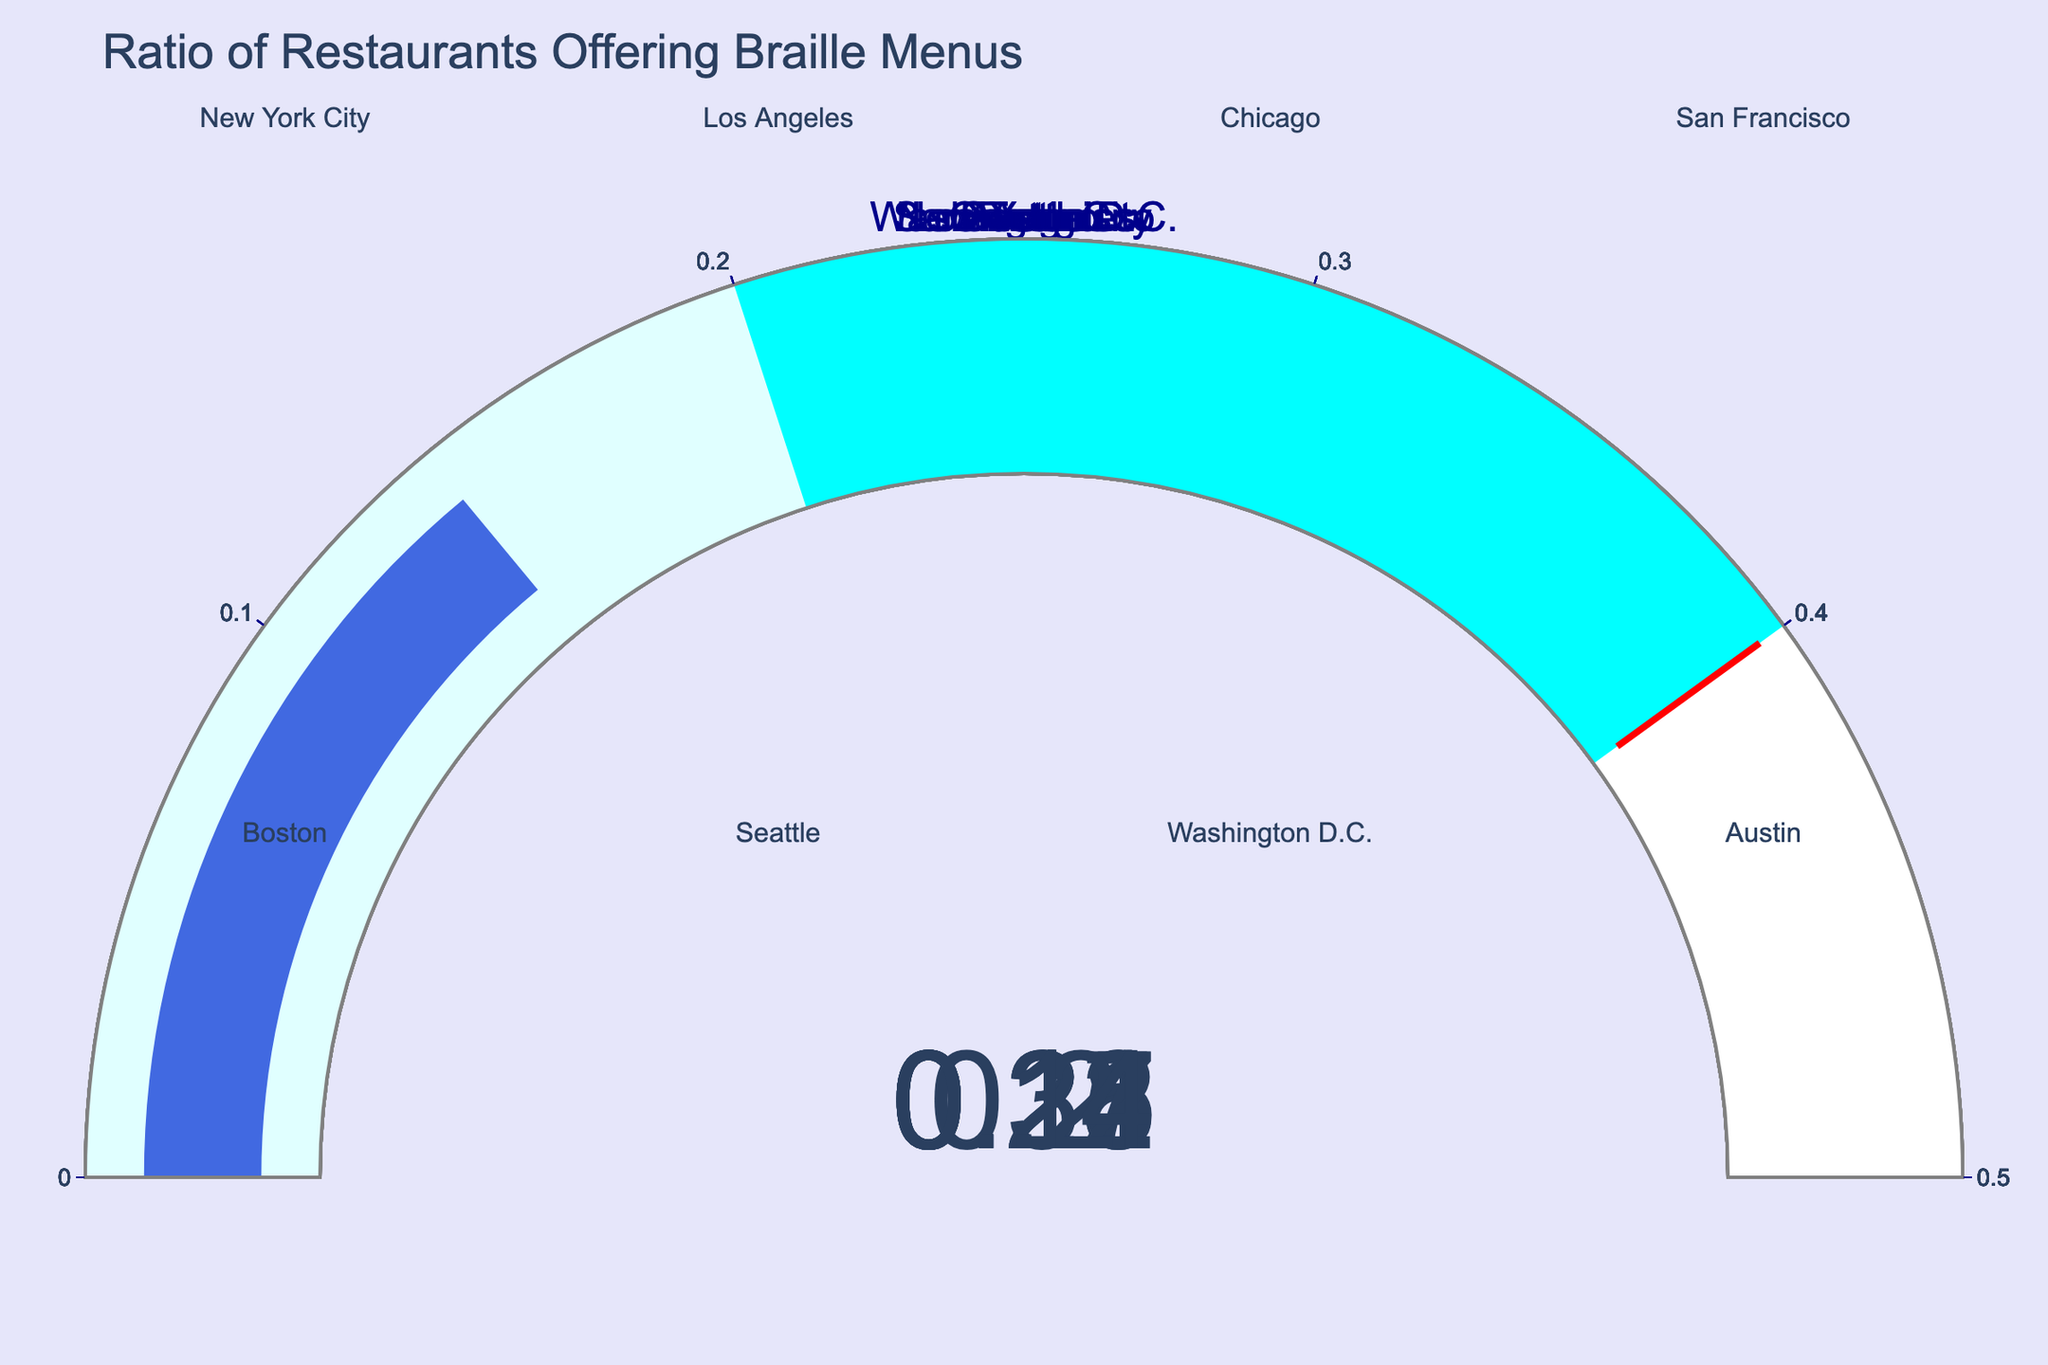What's the ratio of restaurants offering braille menus in San Francisco? The gauge for San Francisco shows a value representing the ratio of restaurants offering braille menus. Looking at the gauge, the value is 0.31.
Answer: 0.31 Which city has the highest ratio of restaurants offering braille menus? By examining each gauge, the city with the highest ratio value is San Francisco, which has a ratio of 0.31, higher than any other city.
Answer: San Francisco Is there any city with a ratio of restaurants offering braille menus greater than 0.3? Looking at the gauges, only San Francisco has a ratio greater than 0.3, showing a value of 0.31.
Answer: Yes, San Francisco How many cities have a ratio of restaurants with braille menus below 0.2? By counting the gauges with values below 0.2: Los Angeles (0.18), Chicago (0.15), Washington D.C. (0.20), and Austin (0.14) fall into this category.
Answer: Four cities What is the average ratio of restaurants offering braille menus in Los Angeles and Boston? The gauges show ratios of 0.18 for Los Angeles and 0.27 for Boston. The average ratio is calculated as (0.18 + 0.27) / 2 = 0.225.
Answer: 0.225 How does the ratio of restaurants offering braille menus in New York City compare to Seattle? The gauge for New York City shows a ratio of 0.23, while Seattle shows 0.22. New York City has a slightly higher value than Seattle.
Answer: New York City has a higher ratio Are there any cities with a ratio exactly at the threshold value of 0.4? None of the gauges show a value at exactly 0.4. All the values are below the threshold indicated by the red line.
Answer: No Among New York City, Chicago, and Austin, which city has the smallest ratio of restaurants offering braille menus? The gauges show ratios of 0.23 for New York City, 0.15 for Chicago, and 0.14 for Austin. Austin has the smallest ratio among these three cities.
Answer: Austin If all cities had twice their current ratios, would San Francisco's ratio still be under the threshold of 0.4? San Francisco's current ratio is 0.31. If it were doubled, it would be 0.31 * 2 = 0.62, which is above the threshold of 0.4.
Answer: No Calculate the sum of the ratios for Seattle and Washington D.C. The gauges show ratios of 0.22 for Seattle and 0.20 for Washington D.C. The sum is 0.22 + 0.20 = 0.42.
Answer: 0.42 